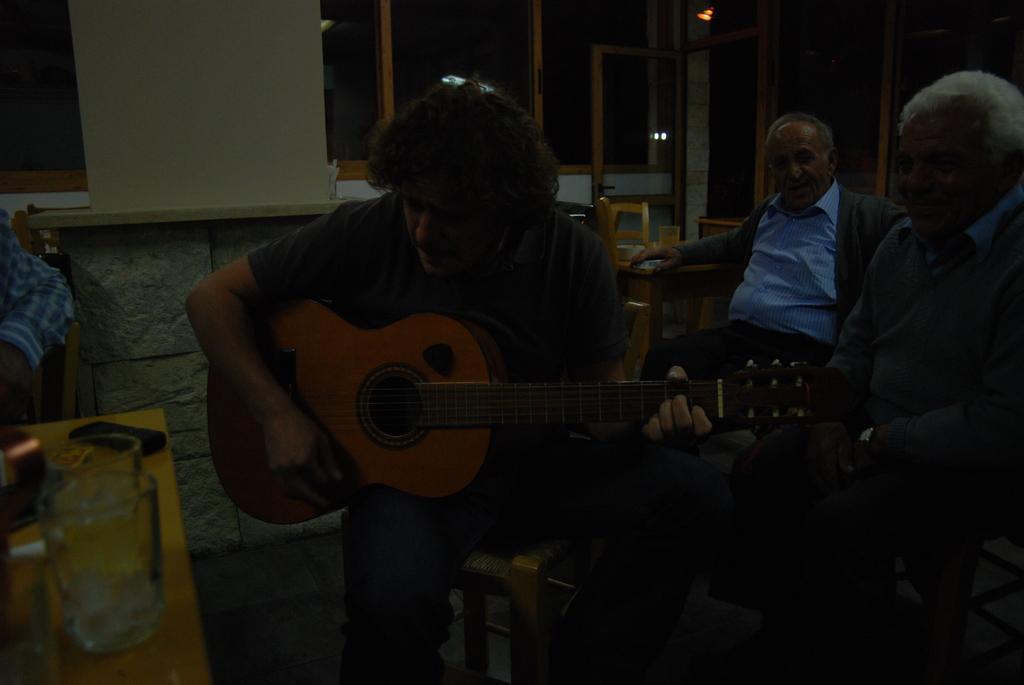Can you describe this image briefly? In this image I see 3 men who are sitting on chairs and this man is holding a guitar. I can also there are tables on which there are glasses and in the background I see the wall. 